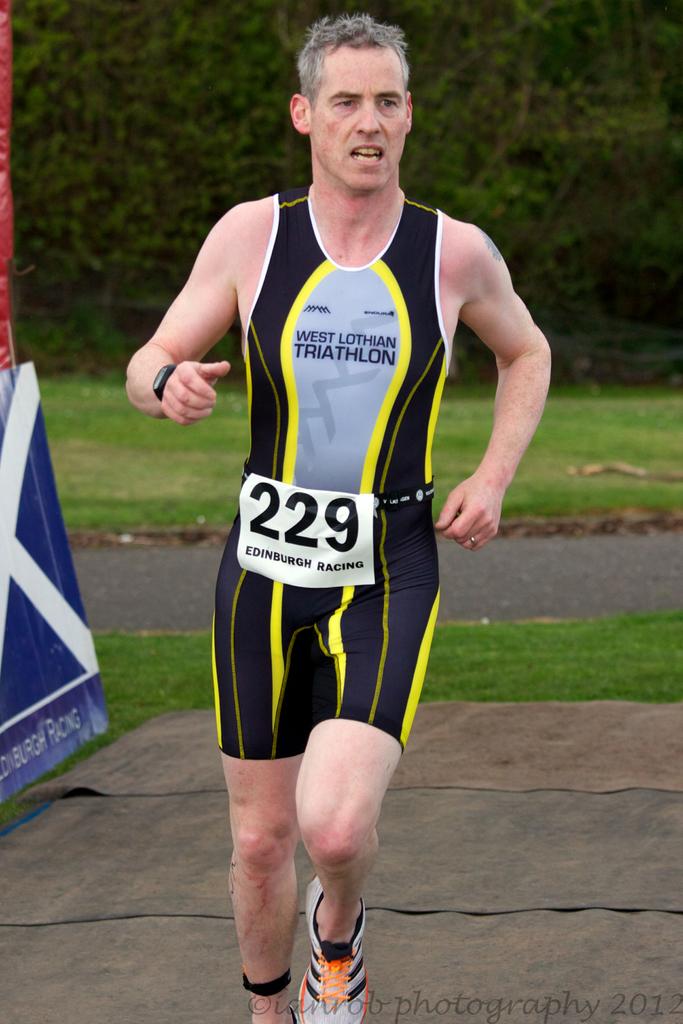What number is this runner?
Your response must be concise. 229. 